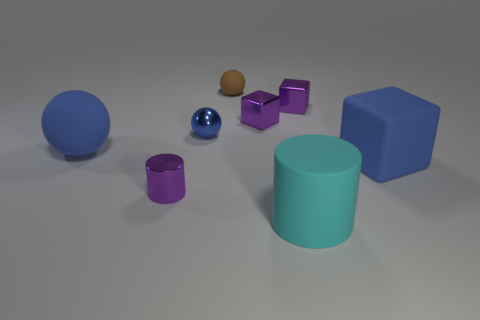Does the small cylinder have the same color as the small rubber ball?
Your answer should be very brief. No. There is a matte cube; is it the same size as the purple object that is on the left side of the blue metallic sphere?
Ensure brevity in your answer.  No. What is the material of the purple thing in front of the big blue rubber object in front of the large blue object behind the blue block?
Your answer should be compact. Metal. What number of things are tiny blue metallic cubes or tiny purple cylinders?
Offer a very short reply. 1. There is a cylinder to the left of the small brown matte object; does it have the same color as the large rubber object that is behind the blue rubber cube?
Offer a very short reply. No. There is a rubber thing that is the same size as the purple cylinder; what is its shape?
Provide a short and direct response. Sphere. How many objects are either small purple metallic objects that are left of the big cylinder or purple metal cylinders left of the blue metal object?
Your response must be concise. 2. Is the number of cyan metallic objects less than the number of metal spheres?
Keep it short and to the point. Yes. There is a brown ball that is the same size as the purple cylinder; what material is it?
Ensure brevity in your answer.  Rubber. Does the rubber sphere left of the brown thing have the same size as the matte sphere that is on the right side of the small cylinder?
Provide a succinct answer. No. 